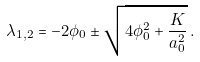Convert formula to latex. <formula><loc_0><loc_0><loc_500><loc_500>\lambda _ { 1 , 2 } = - 2 \phi _ { 0 } \pm \sqrt { 4 \phi _ { 0 } ^ { 2 } + { \frac { K } { a _ { 0 } ^ { 2 } } } } \, .</formula> 